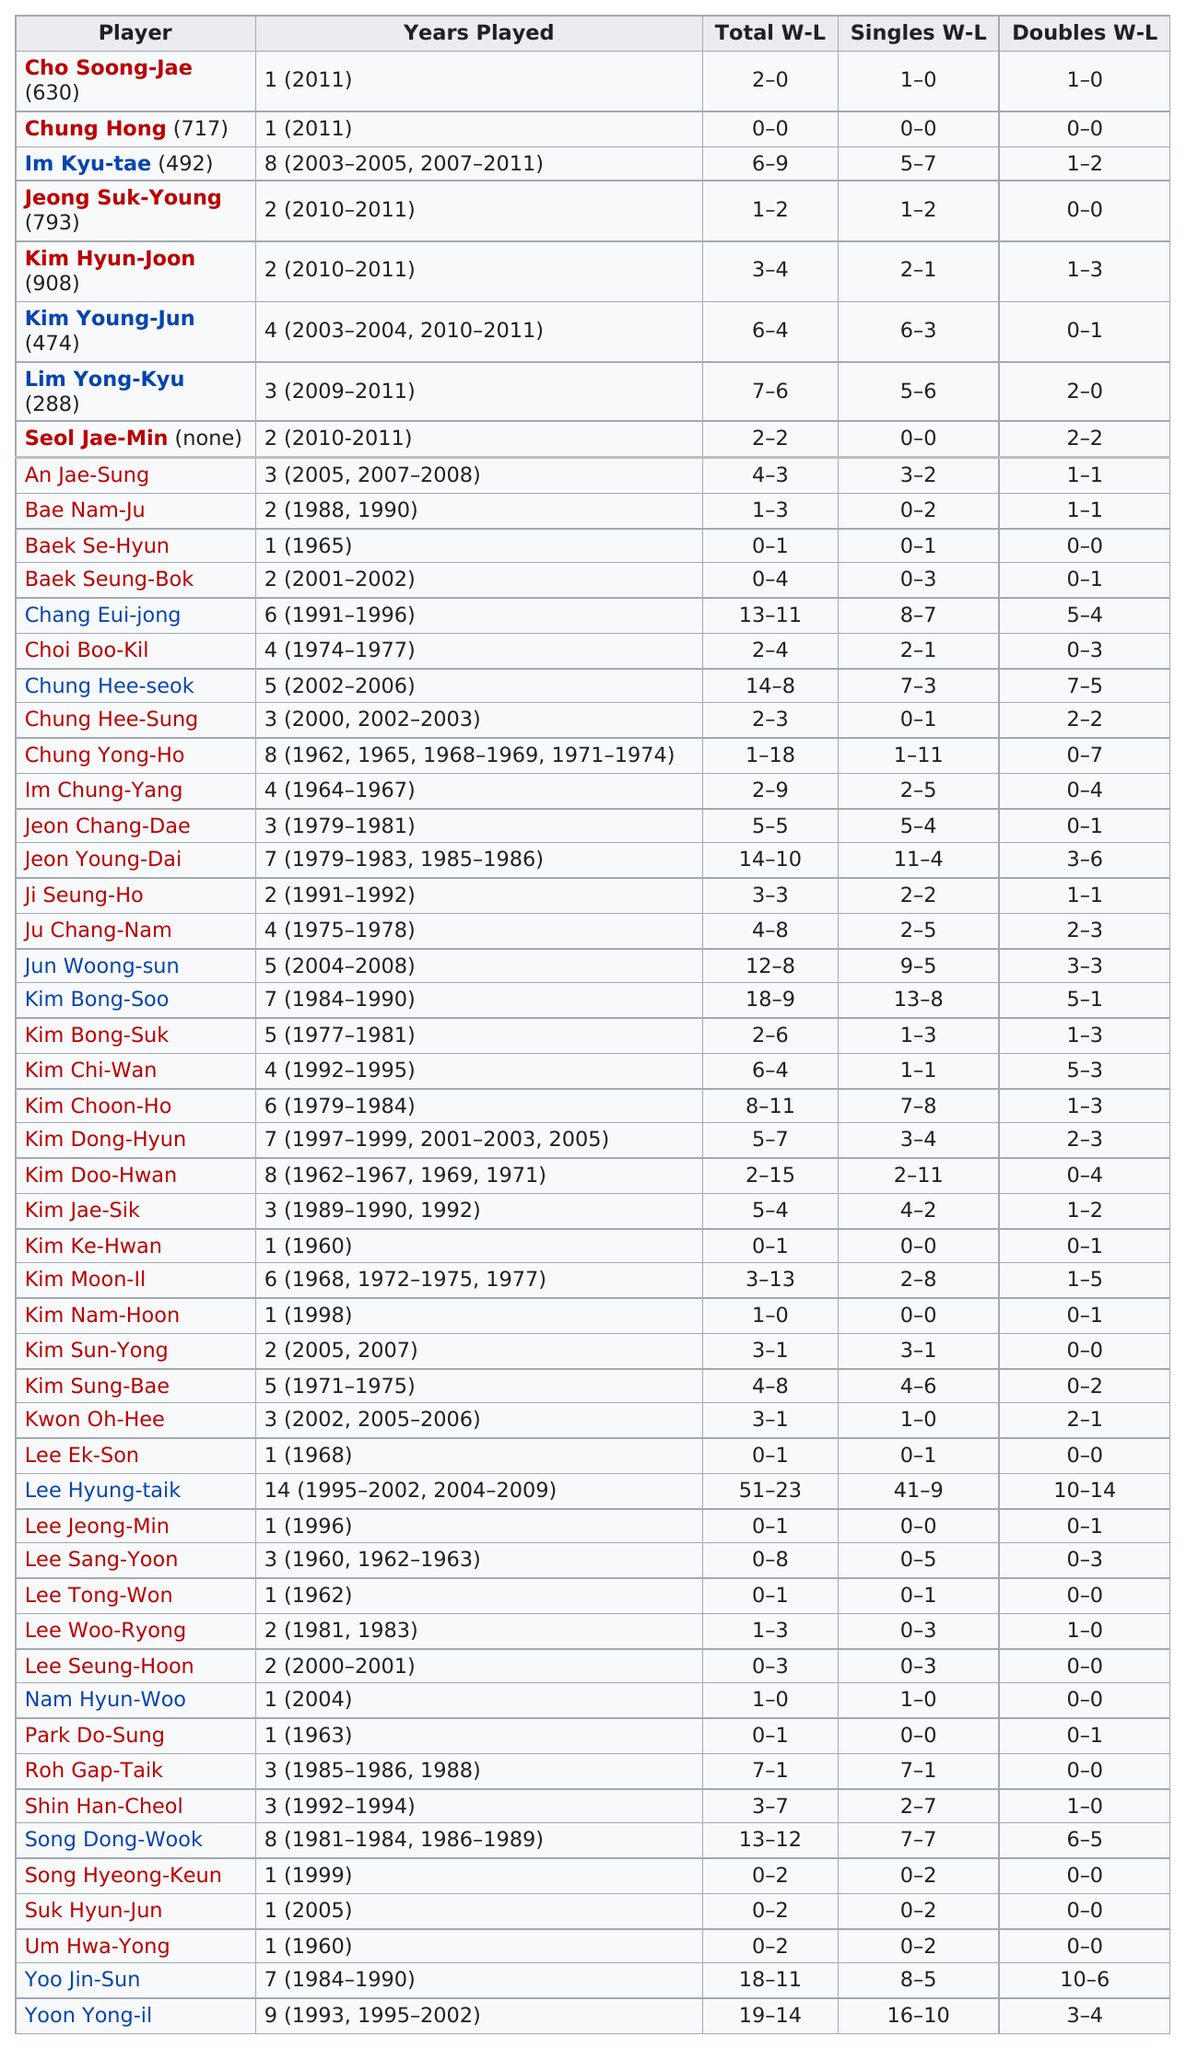Identify some key points in this picture. Boo-Kil had a better singles record than Seung-Bok. Six players went winless with a record of 0-1 across the total win-loss record. It is clear that Kyu-tae was a member of the squad for a longer period of time than Hee-sung, as he was mentioned first in the sentence. Choi Boo-Kil, who had only two losses in the doubles, played with Jae-Sung. It is clear that Eui-jong had more total wins than Se-hyun. 